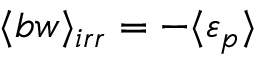Convert formula to latex. <formula><loc_0><loc_0><loc_500><loc_500>\langle b w \rangle _ { i r r } = - \langle \varepsilon _ { p } \rangle</formula> 